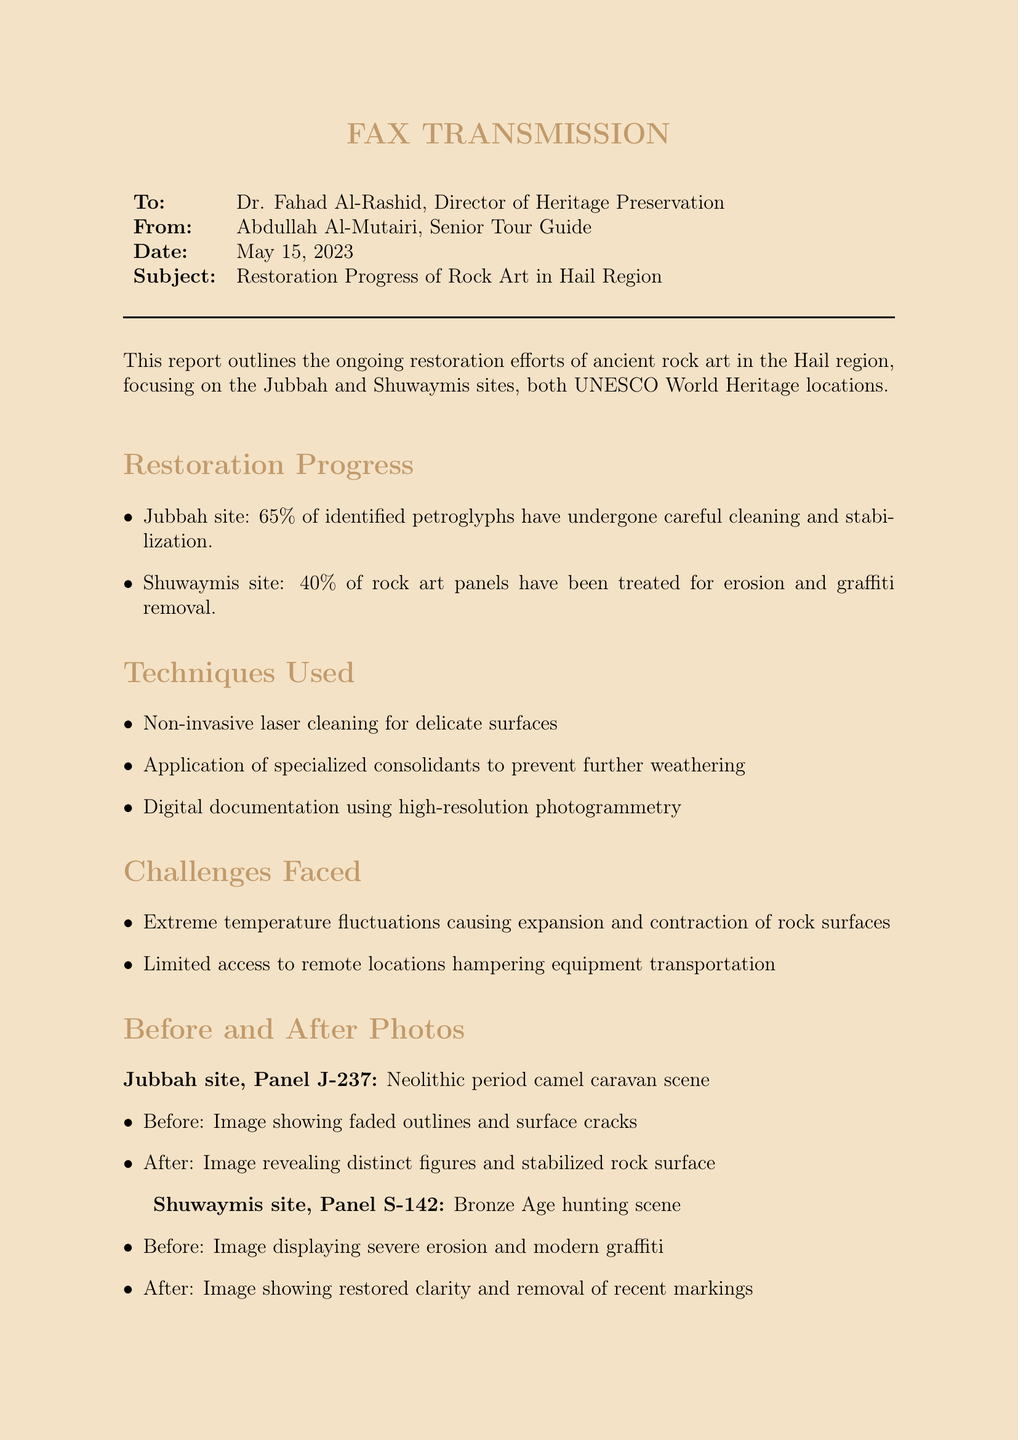What is the date of the fax? The date mentioned in the fax is May 15, 2023.
Answer: May 15, 2023 Who is the sender of the report? The sender of the report is Abdullah Al-Mutairi.
Answer: Abdullah Al-Mutairi What percentage of petroglyphs at Jubbah has undergone restoration? The report states that 65% of identified petroglyphs have undergone restoration.
Answer: 65% What erosion treatment percentage applies to the Shuwaymis site? The Shuwaymis site has had 40% of the rock art panels treated for erosion.
Answer: 40% What type of cleaning technique is used for delicate surfaces? The document mentions the use of non-invasive laser cleaning for delicate surfaces.
Answer: Non-invasive laser cleaning What is one of the challenges faced during the restoration? The report highlights extreme temperature fluctuations as one of the challenges.
Answer: Extreme temperature fluctuations What type of documentation method is employed for the restoration? The method used for documentation is high-resolution photogrammetry.
Answer: High-resolution photogrammetry What is the anticipated completion time for the restoration project? The project anticipates completion within the next 18 months.
Answer: 18 months What is being restored at the Jubbah site? The report mentions the restoration of a Neolithic period camel caravan scene.
Answer: Neolithic period camel caravan scene What is the condition described before the restoration of Panel S-142? The before condition included severe erosion and modern graffiti.
Answer: Severe erosion and modern graffiti 